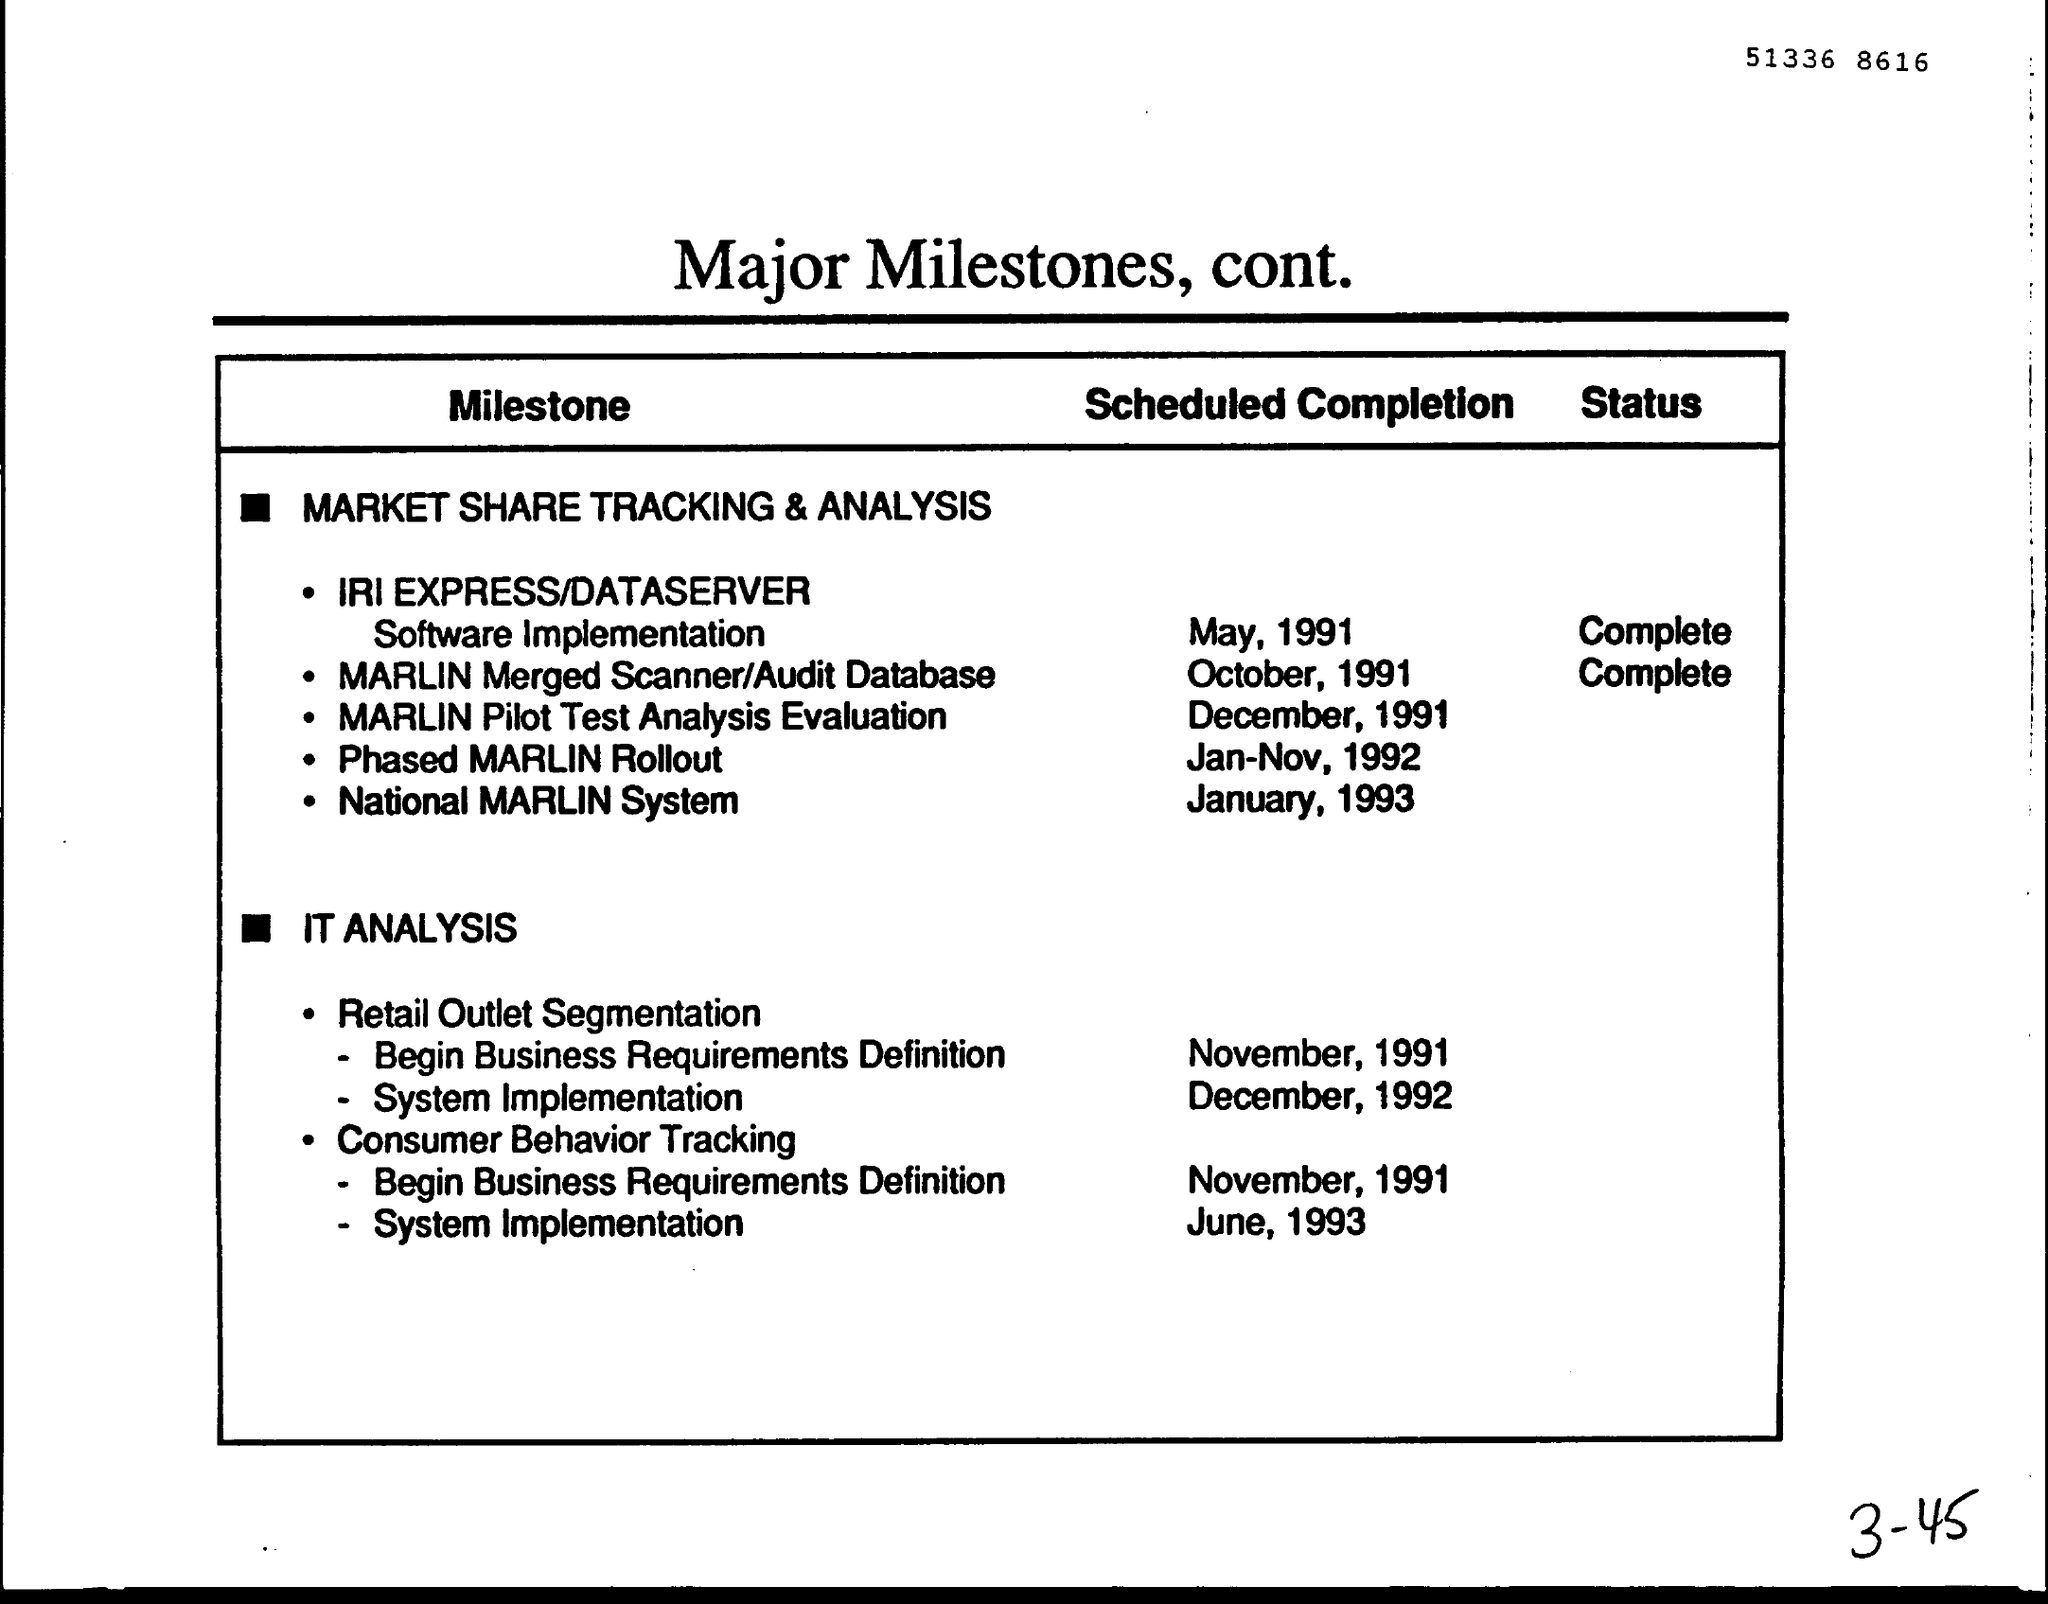Draw attention to some important aspects in this diagram. The document title is Major Milestones, continuing from the previous document, which includes various achievements and significant events during the specified time period. The number written at the top of the page is 51336, followed by 8616, and so on. The scheduled completion of the System Implementation of Retail outlet segmentation is expected to be in December 1992. The MARLIN Merged Scanner/Audit Database is now complete. The completion of the National MARLIN System is scheduled for January, 1993. 